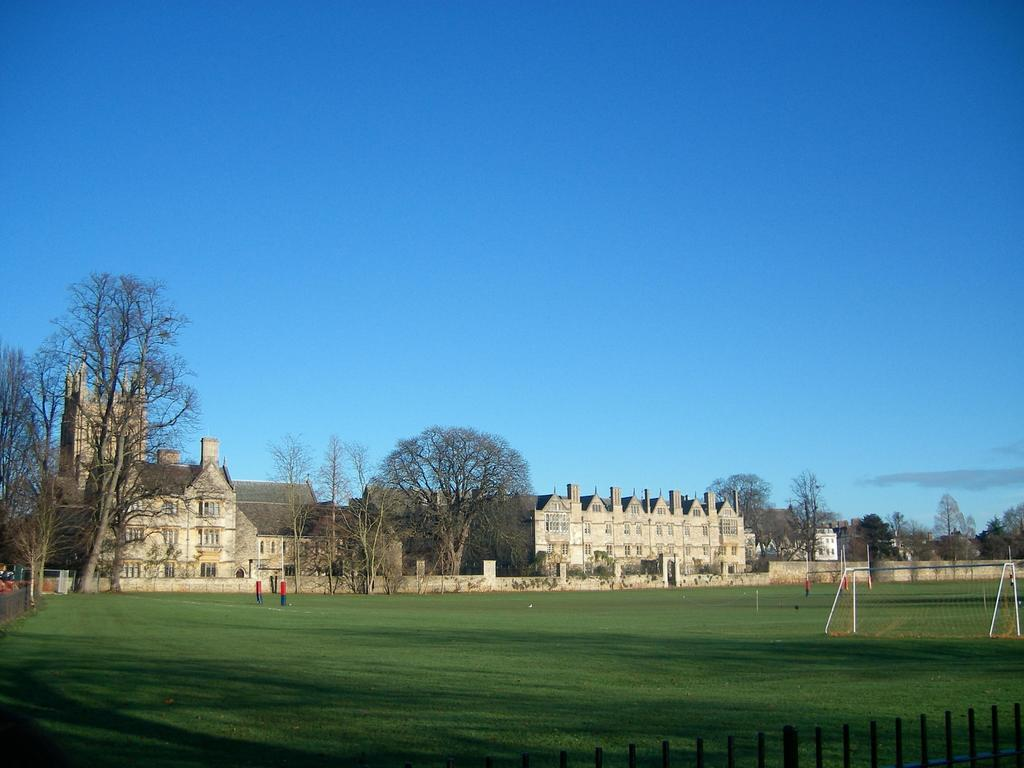What type of surface is on the ground in the image? There is grass on the ground in the image. What sports-related object can be seen on the right side of the image? There is a goal post on the right side of the image. What type of barrier is present in the image? There is a railing in the image. What can be seen in the background of the image? There are trees and buildings with windows in the background. What is visible in the sky in the image? The sky is visible in the image. What type of horn can be heard in the image? There is no horn present in the image, and therefore no sound can be heard. How many birds are sitting on the goal post in the image? There are no birds present in the image, so it is not possible to determine the number of birds on the goal post. 